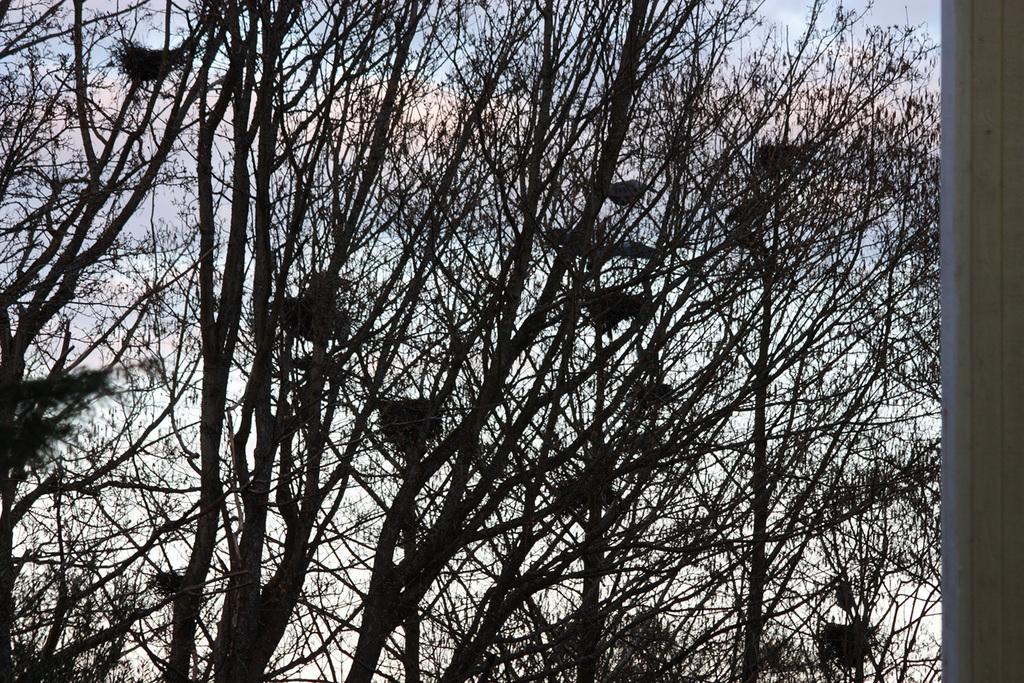Describe this image in one or two sentences. In this image I can see the nests in the trees. In the background, I can see the clouds in the sky. 